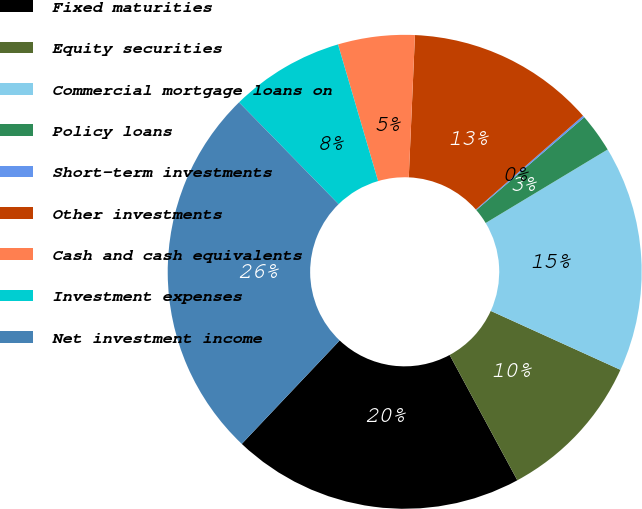Convert chart to OTSL. <chart><loc_0><loc_0><loc_500><loc_500><pie_chart><fcel>Fixed maturities<fcel>Equity securities<fcel>Commercial mortgage loans on<fcel>Policy loans<fcel>Short-term investments<fcel>Other investments<fcel>Cash and cash equivalents<fcel>Investment expenses<fcel>Net investment income<nl><fcel>19.95%<fcel>10.33%<fcel>15.42%<fcel>2.68%<fcel>0.13%<fcel>12.87%<fcel>5.23%<fcel>7.78%<fcel>25.62%<nl></chart> 